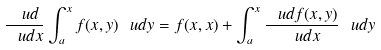<formula> <loc_0><loc_0><loc_500><loc_500>\frac { \ u d } { \ u d x } \int _ { a } ^ { x } f ( x , y ) \ u d y = f ( x , x ) + \int _ { a } ^ { x } \frac { \ u d f ( x , y ) } { \ u d x } \ u d y</formula> 